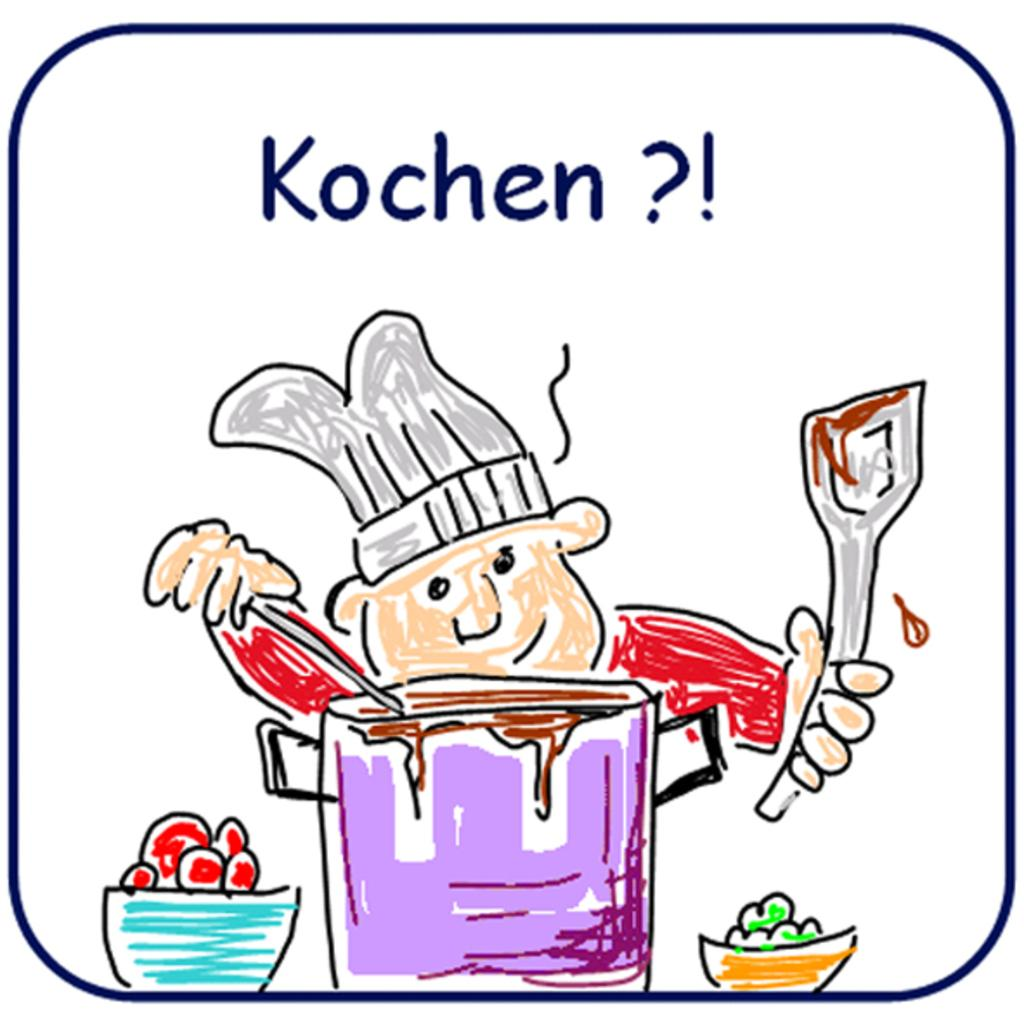What is depicted on the poster in the image? There is a poster with art and text in the image. What is the man in the middle of the image doing? A man is cooking in the middle of the image. What can be seen in the two bowls in the image? There are vegetables in the two bowls in the image. Can you hear the aunt laughing in the image? There is no mention of an aunt or any laughter in the image; it only features a poster, a man cooking, and two bowls with vegetables. 